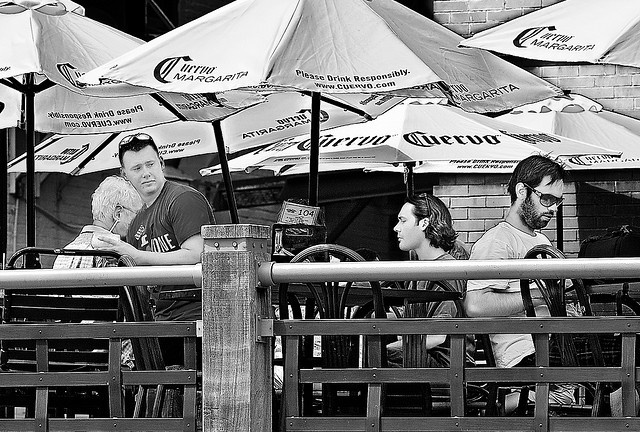Describe the objects in this image and their specific colors. I can see umbrella in white, lightgray, darkgray, black, and gray tones, umbrella in white, black, darkgray, and gray tones, umbrella in white, lightgray, darkgray, black, and gray tones, umbrella in white, lightgray, black, darkgray, and gray tones, and chair in white, black, gray, lightgray, and darkgray tones in this image. 